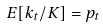<formula> <loc_0><loc_0><loc_500><loc_500>E [ k _ { t } / K ] = p _ { t }</formula> 